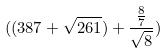<formula> <loc_0><loc_0><loc_500><loc_500>( ( 3 8 7 + \sqrt { 2 6 1 } ) + \frac { \frac { 8 } { 7 } } { \sqrt { 8 } } )</formula> 